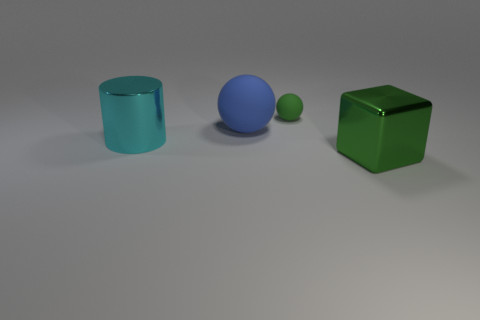Add 4 large green cubes. How many objects exist? 8 Subtract 0 brown cylinders. How many objects are left? 4 Subtract all cylinders. How many objects are left? 3 Subtract all purple spheres. Subtract all brown cubes. How many spheres are left? 2 Subtract all big brown things. Subtract all blocks. How many objects are left? 3 Add 4 blue matte objects. How many blue matte objects are left? 5 Add 3 brown matte cubes. How many brown matte cubes exist? 3 